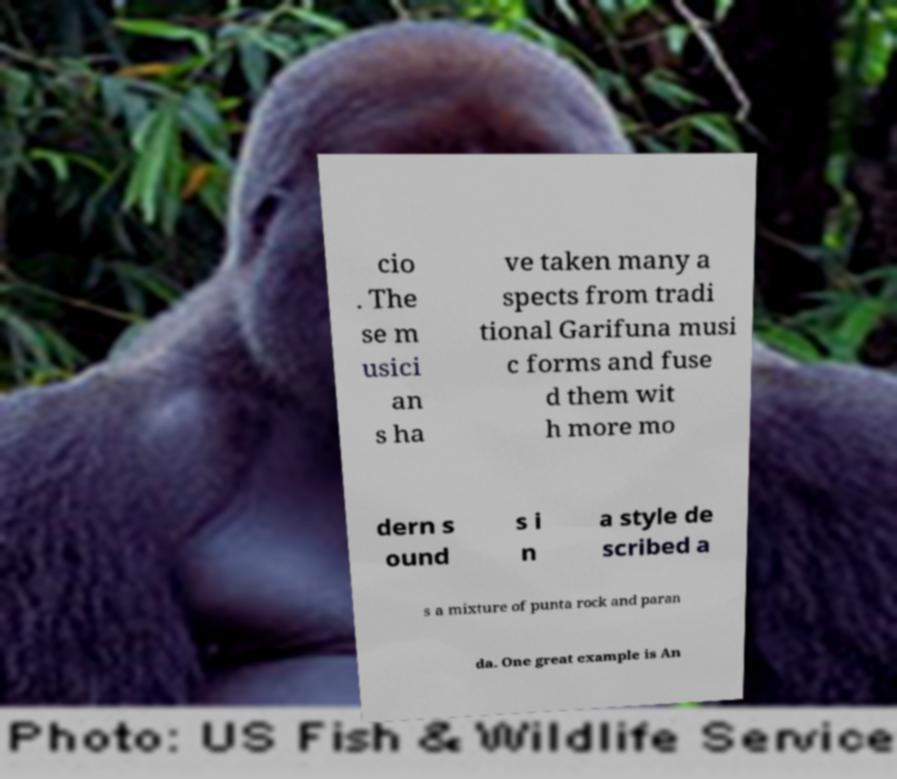Please identify and transcribe the text found in this image. cio . The se m usici an s ha ve taken many a spects from tradi tional Garifuna musi c forms and fuse d them wit h more mo dern s ound s i n a style de scribed a s a mixture of punta rock and paran da. One great example is An 